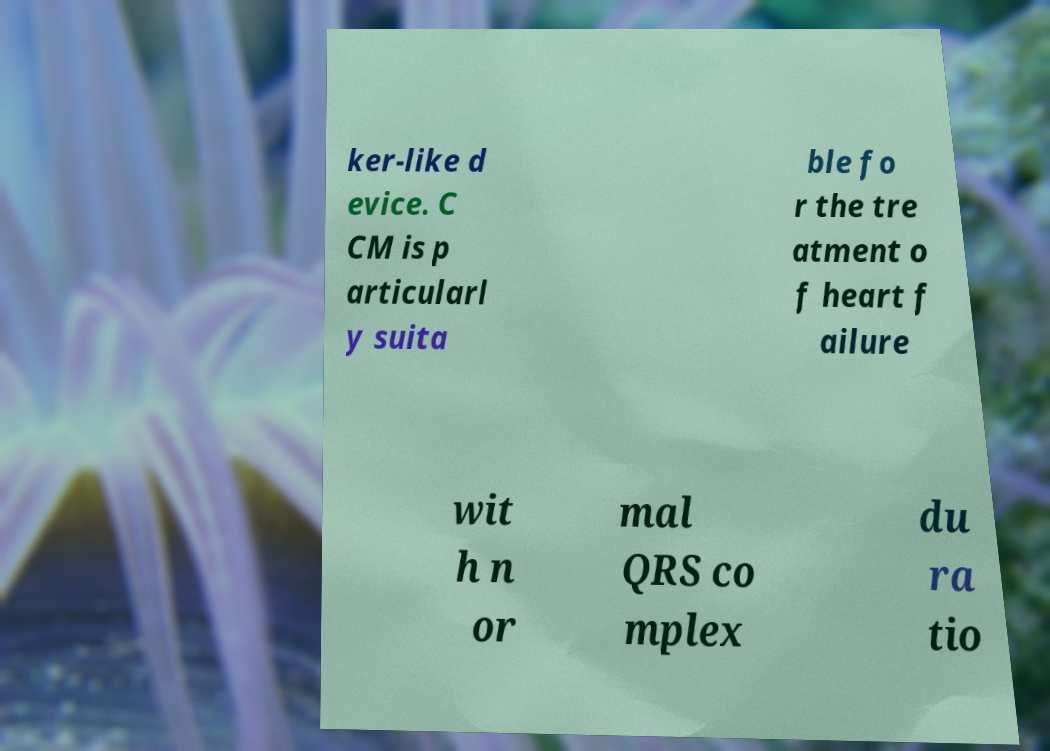Can you read and provide the text displayed in the image?This photo seems to have some interesting text. Can you extract and type it out for me? ker-like d evice. C CM is p articularl y suita ble fo r the tre atment o f heart f ailure wit h n or mal QRS co mplex du ra tio 